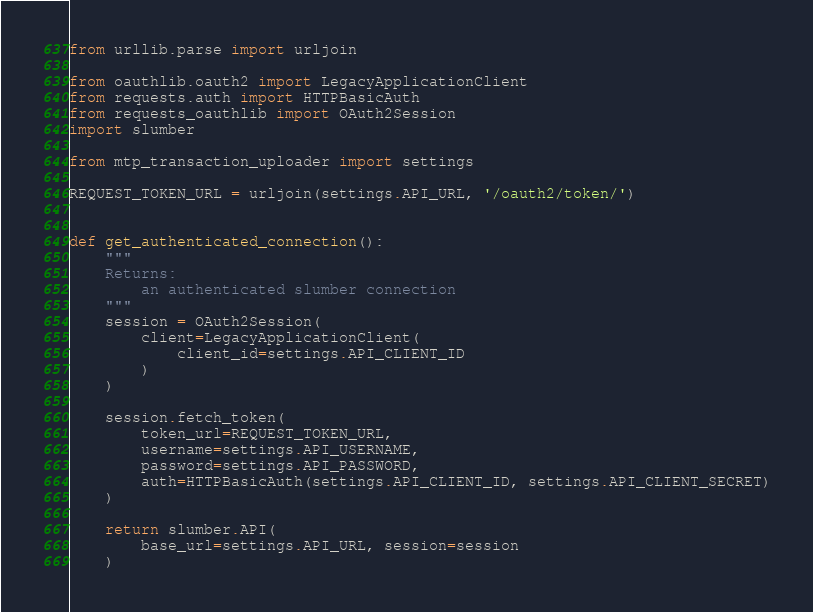<code> <loc_0><loc_0><loc_500><loc_500><_Python_>from urllib.parse import urljoin

from oauthlib.oauth2 import LegacyApplicationClient
from requests.auth import HTTPBasicAuth
from requests_oauthlib import OAuth2Session
import slumber

from mtp_transaction_uploader import settings

REQUEST_TOKEN_URL = urljoin(settings.API_URL, '/oauth2/token/')


def get_authenticated_connection():
    """
    Returns:
        an authenticated slumber connection
    """
    session = OAuth2Session(
        client=LegacyApplicationClient(
            client_id=settings.API_CLIENT_ID
        )
    )

    session.fetch_token(
        token_url=REQUEST_TOKEN_URL,
        username=settings.API_USERNAME,
        password=settings.API_PASSWORD,
        auth=HTTPBasicAuth(settings.API_CLIENT_ID, settings.API_CLIENT_SECRET)
    )

    return slumber.API(
        base_url=settings.API_URL, session=session
    )
</code> 